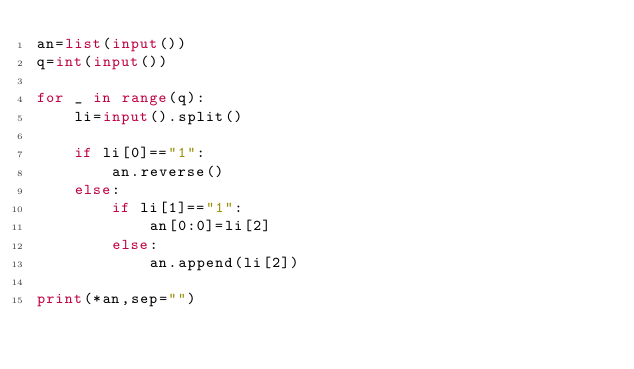Convert code to text. <code><loc_0><loc_0><loc_500><loc_500><_Python_>an=list(input())
q=int(input())

for _ in range(q):
    li=input().split()

    if li[0]=="1":
        an.reverse()
    else:
        if li[1]=="1":
            an[0:0]=li[2]
        else:
            an.append(li[2])

print(*an,sep="")</code> 